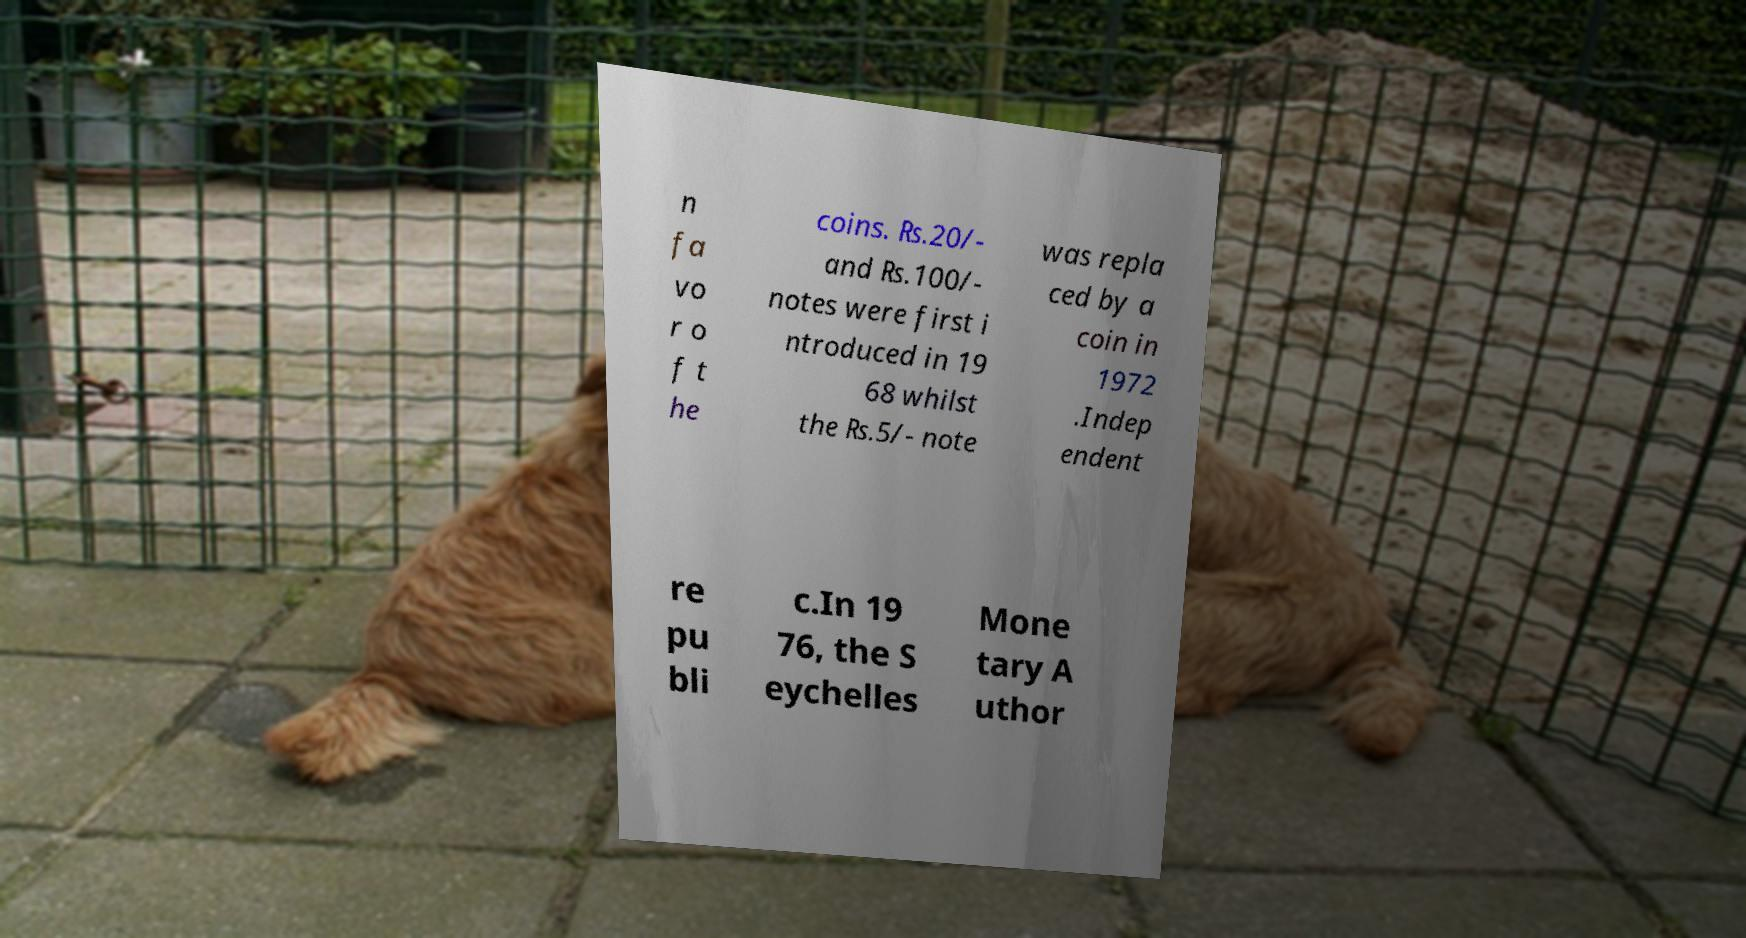Please identify and transcribe the text found in this image. n fa vo r o f t he coins. ₨.20/- and ₨.100/- notes were first i ntroduced in 19 68 whilst the ₨.5/- note was repla ced by a coin in 1972 .Indep endent re pu bli c.In 19 76, the S eychelles Mone tary A uthor 